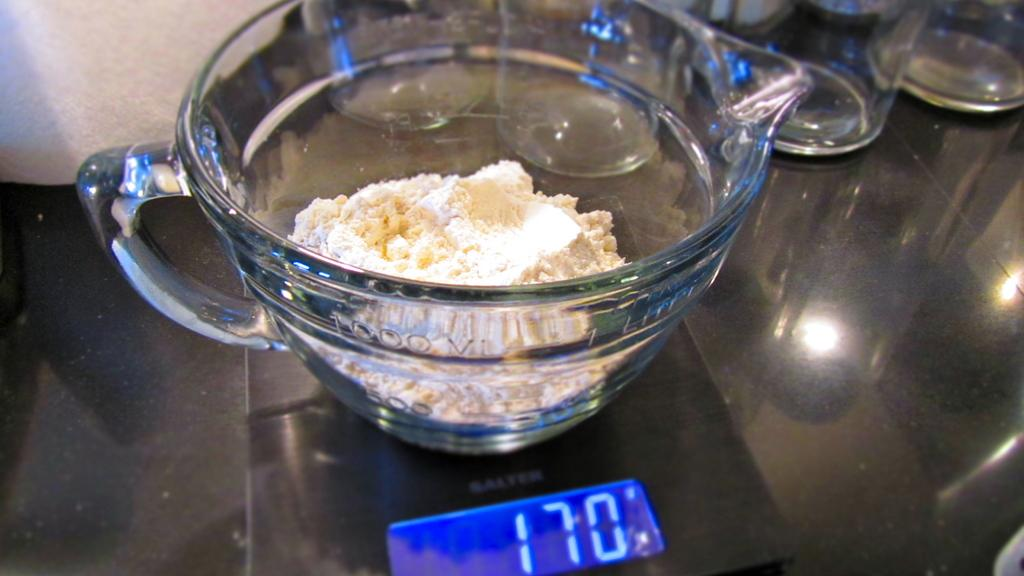Provide a one-sentence caption for the provided image. A bowl of flour and butter on a stove set to 170 degrees. 